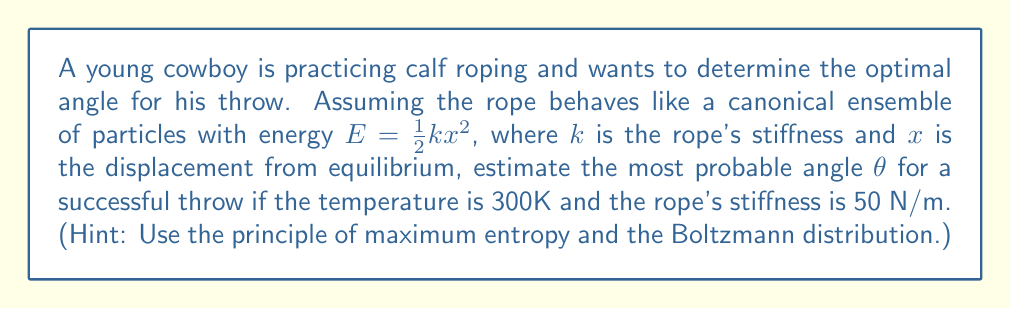Give your solution to this math problem. Let's approach this step-by-step using statistical mechanics principles:

1) In statistical mechanics, the probability of a system being in a particular state is given by the Boltzmann distribution:

   $$P(E) \propto e^{-E/k_BT}$$

   where $k_B$ is the Boltzmann constant and $T$ is the temperature.

2) The energy of the rope is given by $E = \frac{1}{2}kx^2$, where $x = L\sin\theta$, and $L$ is the length of the rope.

3) Substituting this into the Boltzmann distribution:

   $$P(\theta) \propto e^{-\frac{1}{2}kL^2\sin^2\theta / k_BT}$$

4) To find the most probable angle, we need to maximize this probability. This is equivalent to minimizing the exponent:

   $$\frac{d}{d\theta}(\sin^2\theta) = 0$$

5) Solving this:

   $$2\sin\theta\cos\theta = 0$$

   This is satisfied when $\theta = 0$, $\frac{\pi}{2}$, or $\pi$.

6) The second derivative test shows that $\theta = 0$ and $\theta = \pi$ are maxima (less probable), while $\theta = \frac{\pi}{2}$ is a minimum (most probable).

7) Therefore, the most probable angle for a successful throw is $\frac{\pi}{2}$ or 90 degrees.

Note that this result is independent of the temperature, rope stiffness, and length, which is a consequence of the simple model we used. In reality, other factors would influence the optimal angle.
Answer: 90 degrees 